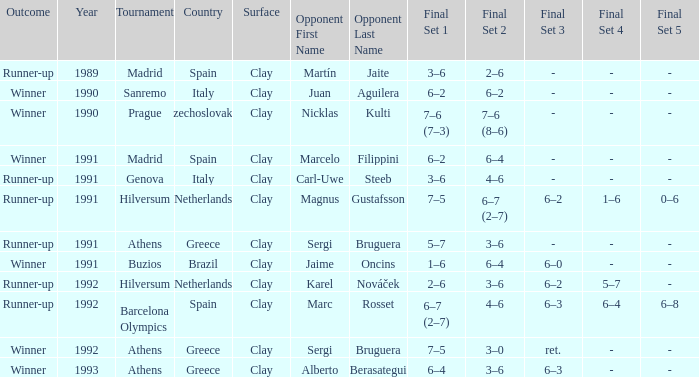What is Opponent In The Final, when Date is before 1991, and when Outcome is "Runner-Up"? Martín Jaite. 